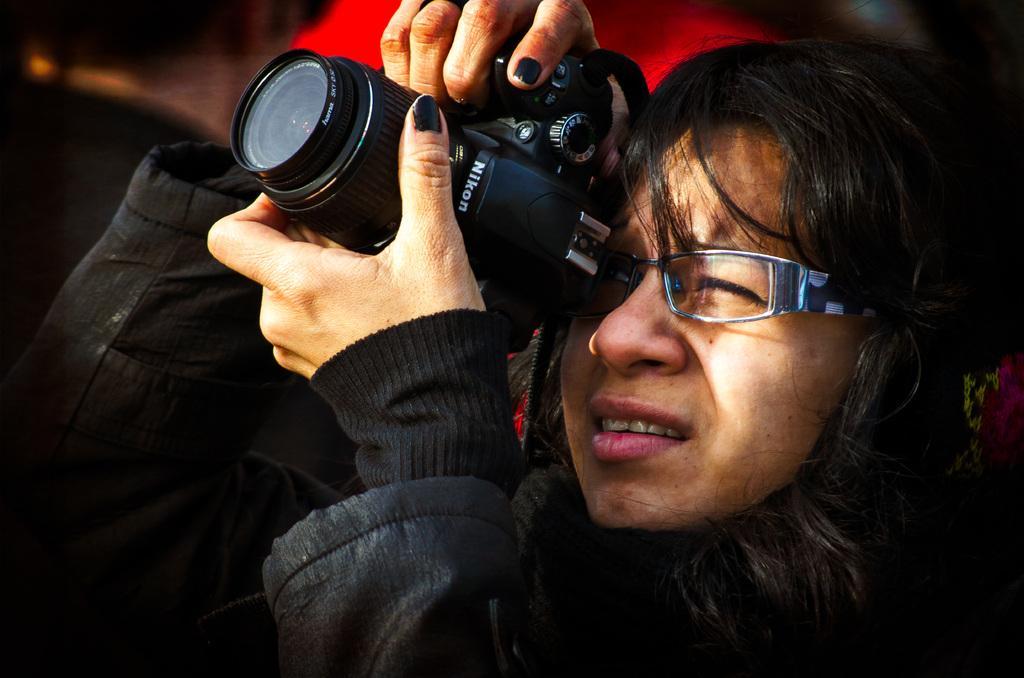Could you give a brief overview of what you see in this image? In this image I can see the person with black color dress and specs. The person is holding the camera which is in black color. And I can see the red color object and there is a blurred background. 